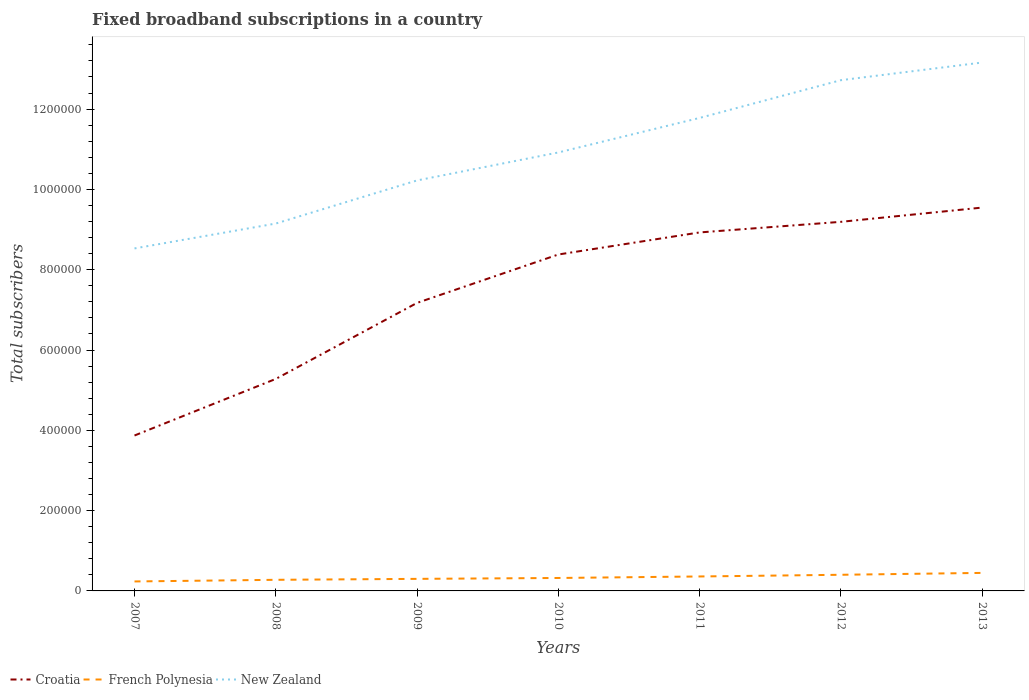Is the number of lines equal to the number of legend labels?
Your response must be concise. Yes. Across all years, what is the maximum number of broadband subscriptions in French Polynesia?
Provide a short and direct response. 2.36e+04. In which year was the number of broadband subscriptions in French Polynesia maximum?
Offer a terse response. 2007. What is the total number of broadband subscriptions in Croatia in the graph?
Your answer should be very brief. -2.64e+04. What is the difference between the highest and the second highest number of broadband subscriptions in Croatia?
Provide a succinct answer. 5.68e+05. What is the difference between the highest and the lowest number of broadband subscriptions in French Polynesia?
Ensure brevity in your answer.  3. How many lines are there?
Your answer should be compact. 3. What is the difference between two consecutive major ticks on the Y-axis?
Your answer should be compact. 2.00e+05. Does the graph contain any zero values?
Keep it short and to the point. No. Does the graph contain grids?
Keep it short and to the point. No. How many legend labels are there?
Keep it short and to the point. 3. What is the title of the graph?
Your response must be concise. Fixed broadband subscriptions in a country. What is the label or title of the Y-axis?
Your answer should be compact. Total subscribers. What is the Total subscribers in Croatia in 2007?
Provide a succinct answer. 3.87e+05. What is the Total subscribers in French Polynesia in 2007?
Make the answer very short. 2.36e+04. What is the Total subscribers of New Zealand in 2007?
Offer a terse response. 8.53e+05. What is the Total subscribers in Croatia in 2008?
Your answer should be compact. 5.28e+05. What is the Total subscribers of French Polynesia in 2008?
Keep it short and to the point. 2.77e+04. What is the Total subscribers of New Zealand in 2008?
Provide a short and direct response. 9.15e+05. What is the Total subscribers of Croatia in 2009?
Your response must be concise. 7.17e+05. What is the Total subscribers in French Polynesia in 2009?
Offer a terse response. 3.00e+04. What is the Total subscribers in New Zealand in 2009?
Provide a short and direct response. 1.02e+06. What is the Total subscribers of Croatia in 2010?
Your answer should be compact. 8.38e+05. What is the Total subscribers in French Polynesia in 2010?
Make the answer very short. 3.22e+04. What is the Total subscribers of New Zealand in 2010?
Give a very brief answer. 1.09e+06. What is the Total subscribers in Croatia in 2011?
Ensure brevity in your answer.  8.93e+05. What is the Total subscribers in French Polynesia in 2011?
Your answer should be very brief. 3.60e+04. What is the Total subscribers of New Zealand in 2011?
Provide a short and direct response. 1.18e+06. What is the Total subscribers of Croatia in 2012?
Provide a succinct answer. 9.19e+05. What is the Total subscribers of French Polynesia in 2012?
Keep it short and to the point. 4.02e+04. What is the Total subscribers in New Zealand in 2012?
Your response must be concise. 1.27e+06. What is the Total subscribers in Croatia in 2013?
Your answer should be very brief. 9.55e+05. What is the Total subscribers of French Polynesia in 2013?
Offer a terse response. 4.49e+04. What is the Total subscribers in New Zealand in 2013?
Your answer should be compact. 1.32e+06. Across all years, what is the maximum Total subscribers of Croatia?
Provide a succinct answer. 9.55e+05. Across all years, what is the maximum Total subscribers in French Polynesia?
Ensure brevity in your answer.  4.49e+04. Across all years, what is the maximum Total subscribers in New Zealand?
Provide a short and direct response. 1.32e+06. Across all years, what is the minimum Total subscribers of Croatia?
Offer a very short reply. 3.87e+05. Across all years, what is the minimum Total subscribers in French Polynesia?
Provide a succinct answer. 2.36e+04. Across all years, what is the minimum Total subscribers in New Zealand?
Your answer should be very brief. 8.53e+05. What is the total Total subscribers in Croatia in the graph?
Keep it short and to the point. 5.24e+06. What is the total Total subscribers in French Polynesia in the graph?
Your answer should be very brief. 2.35e+05. What is the total Total subscribers of New Zealand in the graph?
Keep it short and to the point. 7.65e+06. What is the difference between the Total subscribers of Croatia in 2007 and that in 2008?
Your answer should be very brief. -1.41e+05. What is the difference between the Total subscribers of French Polynesia in 2007 and that in 2008?
Make the answer very short. -4071. What is the difference between the Total subscribers in New Zealand in 2007 and that in 2008?
Provide a short and direct response. -6.19e+04. What is the difference between the Total subscribers in Croatia in 2007 and that in 2009?
Keep it short and to the point. -3.30e+05. What is the difference between the Total subscribers in French Polynesia in 2007 and that in 2009?
Your answer should be compact. -6430. What is the difference between the Total subscribers of New Zealand in 2007 and that in 2009?
Ensure brevity in your answer.  -1.69e+05. What is the difference between the Total subscribers of Croatia in 2007 and that in 2010?
Provide a short and direct response. -4.51e+05. What is the difference between the Total subscribers of French Polynesia in 2007 and that in 2010?
Keep it short and to the point. -8647. What is the difference between the Total subscribers of New Zealand in 2007 and that in 2010?
Ensure brevity in your answer.  -2.39e+05. What is the difference between the Total subscribers in Croatia in 2007 and that in 2011?
Ensure brevity in your answer.  -5.06e+05. What is the difference between the Total subscribers in French Polynesia in 2007 and that in 2011?
Provide a short and direct response. -1.24e+04. What is the difference between the Total subscribers of New Zealand in 2007 and that in 2011?
Make the answer very short. -3.25e+05. What is the difference between the Total subscribers of Croatia in 2007 and that in 2012?
Your answer should be very brief. -5.32e+05. What is the difference between the Total subscribers of French Polynesia in 2007 and that in 2012?
Your answer should be compact. -1.66e+04. What is the difference between the Total subscribers of New Zealand in 2007 and that in 2012?
Provide a short and direct response. -4.19e+05. What is the difference between the Total subscribers of Croatia in 2007 and that in 2013?
Offer a terse response. -5.68e+05. What is the difference between the Total subscribers in French Polynesia in 2007 and that in 2013?
Your response must be concise. -2.13e+04. What is the difference between the Total subscribers in New Zealand in 2007 and that in 2013?
Provide a succinct answer. -4.63e+05. What is the difference between the Total subscribers in Croatia in 2008 and that in 2009?
Ensure brevity in your answer.  -1.89e+05. What is the difference between the Total subscribers of French Polynesia in 2008 and that in 2009?
Make the answer very short. -2359. What is the difference between the Total subscribers in New Zealand in 2008 and that in 2009?
Keep it short and to the point. -1.07e+05. What is the difference between the Total subscribers in Croatia in 2008 and that in 2010?
Your answer should be very brief. -3.10e+05. What is the difference between the Total subscribers in French Polynesia in 2008 and that in 2010?
Provide a short and direct response. -4576. What is the difference between the Total subscribers in New Zealand in 2008 and that in 2010?
Your response must be concise. -1.77e+05. What is the difference between the Total subscribers of Croatia in 2008 and that in 2011?
Your answer should be compact. -3.65e+05. What is the difference between the Total subscribers of French Polynesia in 2008 and that in 2011?
Make the answer very short. -8329. What is the difference between the Total subscribers of New Zealand in 2008 and that in 2011?
Make the answer very short. -2.63e+05. What is the difference between the Total subscribers in Croatia in 2008 and that in 2012?
Provide a succinct answer. -3.91e+05. What is the difference between the Total subscribers in French Polynesia in 2008 and that in 2012?
Your answer should be compact. -1.25e+04. What is the difference between the Total subscribers of New Zealand in 2008 and that in 2012?
Your response must be concise. -3.57e+05. What is the difference between the Total subscribers of Croatia in 2008 and that in 2013?
Provide a short and direct response. -4.27e+05. What is the difference between the Total subscribers in French Polynesia in 2008 and that in 2013?
Give a very brief answer. -1.72e+04. What is the difference between the Total subscribers in New Zealand in 2008 and that in 2013?
Ensure brevity in your answer.  -4.01e+05. What is the difference between the Total subscribers in Croatia in 2009 and that in 2010?
Provide a succinct answer. -1.21e+05. What is the difference between the Total subscribers of French Polynesia in 2009 and that in 2010?
Give a very brief answer. -2217. What is the difference between the Total subscribers in New Zealand in 2009 and that in 2010?
Offer a very short reply. -6.97e+04. What is the difference between the Total subscribers in Croatia in 2009 and that in 2011?
Ensure brevity in your answer.  -1.75e+05. What is the difference between the Total subscribers in French Polynesia in 2009 and that in 2011?
Your response must be concise. -5970. What is the difference between the Total subscribers in New Zealand in 2009 and that in 2011?
Keep it short and to the point. -1.56e+05. What is the difference between the Total subscribers of Croatia in 2009 and that in 2012?
Ensure brevity in your answer.  -2.02e+05. What is the difference between the Total subscribers of French Polynesia in 2009 and that in 2012?
Provide a short and direct response. -1.02e+04. What is the difference between the Total subscribers of New Zealand in 2009 and that in 2012?
Keep it short and to the point. -2.50e+05. What is the difference between the Total subscribers of Croatia in 2009 and that in 2013?
Give a very brief answer. -2.37e+05. What is the difference between the Total subscribers of French Polynesia in 2009 and that in 2013?
Give a very brief answer. -1.49e+04. What is the difference between the Total subscribers of New Zealand in 2009 and that in 2013?
Your answer should be very brief. -2.94e+05. What is the difference between the Total subscribers in Croatia in 2010 and that in 2011?
Keep it short and to the point. -5.50e+04. What is the difference between the Total subscribers of French Polynesia in 2010 and that in 2011?
Provide a short and direct response. -3753. What is the difference between the Total subscribers of New Zealand in 2010 and that in 2011?
Keep it short and to the point. -8.60e+04. What is the difference between the Total subscribers of Croatia in 2010 and that in 2012?
Provide a succinct answer. -8.14e+04. What is the difference between the Total subscribers of French Polynesia in 2010 and that in 2012?
Your response must be concise. -7953. What is the difference between the Total subscribers of Croatia in 2010 and that in 2013?
Ensure brevity in your answer.  -1.17e+05. What is the difference between the Total subscribers of French Polynesia in 2010 and that in 2013?
Ensure brevity in your answer.  -1.27e+04. What is the difference between the Total subscribers in New Zealand in 2010 and that in 2013?
Offer a terse response. -2.24e+05. What is the difference between the Total subscribers in Croatia in 2011 and that in 2012?
Your answer should be very brief. -2.64e+04. What is the difference between the Total subscribers of French Polynesia in 2011 and that in 2012?
Give a very brief answer. -4200. What is the difference between the Total subscribers of New Zealand in 2011 and that in 2012?
Give a very brief answer. -9.40e+04. What is the difference between the Total subscribers of Croatia in 2011 and that in 2013?
Offer a terse response. -6.19e+04. What is the difference between the Total subscribers of French Polynesia in 2011 and that in 2013?
Your answer should be very brief. -8900. What is the difference between the Total subscribers in New Zealand in 2011 and that in 2013?
Your answer should be compact. -1.38e+05. What is the difference between the Total subscribers in Croatia in 2012 and that in 2013?
Your answer should be very brief. -3.55e+04. What is the difference between the Total subscribers in French Polynesia in 2012 and that in 2013?
Offer a terse response. -4700. What is the difference between the Total subscribers in New Zealand in 2012 and that in 2013?
Provide a short and direct response. -4.40e+04. What is the difference between the Total subscribers of Croatia in 2007 and the Total subscribers of French Polynesia in 2008?
Your answer should be compact. 3.59e+05. What is the difference between the Total subscribers of Croatia in 2007 and the Total subscribers of New Zealand in 2008?
Your answer should be very brief. -5.28e+05. What is the difference between the Total subscribers in French Polynesia in 2007 and the Total subscribers in New Zealand in 2008?
Your response must be concise. -8.91e+05. What is the difference between the Total subscribers of Croatia in 2007 and the Total subscribers of French Polynesia in 2009?
Offer a terse response. 3.57e+05. What is the difference between the Total subscribers in Croatia in 2007 and the Total subscribers in New Zealand in 2009?
Offer a very short reply. -6.35e+05. What is the difference between the Total subscribers of French Polynesia in 2007 and the Total subscribers of New Zealand in 2009?
Give a very brief answer. -9.99e+05. What is the difference between the Total subscribers of Croatia in 2007 and the Total subscribers of French Polynesia in 2010?
Offer a terse response. 3.55e+05. What is the difference between the Total subscribers in Croatia in 2007 and the Total subscribers in New Zealand in 2010?
Give a very brief answer. -7.05e+05. What is the difference between the Total subscribers in French Polynesia in 2007 and the Total subscribers in New Zealand in 2010?
Provide a short and direct response. -1.07e+06. What is the difference between the Total subscribers in Croatia in 2007 and the Total subscribers in French Polynesia in 2011?
Ensure brevity in your answer.  3.51e+05. What is the difference between the Total subscribers of Croatia in 2007 and the Total subscribers of New Zealand in 2011?
Provide a short and direct response. -7.91e+05. What is the difference between the Total subscribers in French Polynesia in 2007 and the Total subscribers in New Zealand in 2011?
Provide a short and direct response. -1.15e+06. What is the difference between the Total subscribers of Croatia in 2007 and the Total subscribers of French Polynesia in 2012?
Make the answer very short. 3.47e+05. What is the difference between the Total subscribers in Croatia in 2007 and the Total subscribers in New Zealand in 2012?
Offer a terse response. -8.85e+05. What is the difference between the Total subscribers in French Polynesia in 2007 and the Total subscribers in New Zealand in 2012?
Your answer should be very brief. -1.25e+06. What is the difference between the Total subscribers of Croatia in 2007 and the Total subscribers of French Polynesia in 2013?
Your answer should be very brief. 3.42e+05. What is the difference between the Total subscribers of Croatia in 2007 and the Total subscribers of New Zealand in 2013?
Your response must be concise. -9.29e+05. What is the difference between the Total subscribers in French Polynesia in 2007 and the Total subscribers in New Zealand in 2013?
Provide a succinct answer. -1.29e+06. What is the difference between the Total subscribers in Croatia in 2008 and the Total subscribers in French Polynesia in 2009?
Offer a terse response. 4.98e+05. What is the difference between the Total subscribers of Croatia in 2008 and the Total subscribers of New Zealand in 2009?
Give a very brief answer. -4.94e+05. What is the difference between the Total subscribers of French Polynesia in 2008 and the Total subscribers of New Zealand in 2009?
Your answer should be very brief. -9.95e+05. What is the difference between the Total subscribers of Croatia in 2008 and the Total subscribers of French Polynesia in 2010?
Provide a short and direct response. 4.96e+05. What is the difference between the Total subscribers of Croatia in 2008 and the Total subscribers of New Zealand in 2010?
Provide a succinct answer. -5.64e+05. What is the difference between the Total subscribers in French Polynesia in 2008 and the Total subscribers in New Zealand in 2010?
Your answer should be very brief. -1.06e+06. What is the difference between the Total subscribers of Croatia in 2008 and the Total subscribers of French Polynesia in 2011?
Your response must be concise. 4.92e+05. What is the difference between the Total subscribers of Croatia in 2008 and the Total subscribers of New Zealand in 2011?
Offer a terse response. -6.50e+05. What is the difference between the Total subscribers in French Polynesia in 2008 and the Total subscribers in New Zealand in 2011?
Offer a very short reply. -1.15e+06. What is the difference between the Total subscribers in Croatia in 2008 and the Total subscribers in French Polynesia in 2012?
Your response must be concise. 4.88e+05. What is the difference between the Total subscribers in Croatia in 2008 and the Total subscribers in New Zealand in 2012?
Your answer should be compact. -7.44e+05. What is the difference between the Total subscribers in French Polynesia in 2008 and the Total subscribers in New Zealand in 2012?
Your response must be concise. -1.24e+06. What is the difference between the Total subscribers in Croatia in 2008 and the Total subscribers in French Polynesia in 2013?
Your answer should be compact. 4.83e+05. What is the difference between the Total subscribers of Croatia in 2008 and the Total subscribers of New Zealand in 2013?
Ensure brevity in your answer.  -7.88e+05. What is the difference between the Total subscribers in French Polynesia in 2008 and the Total subscribers in New Zealand in 2013?
Provide a succinct answer. -1.29e+06. What is the difference between the Total subscribers of Croatia in 2009 and the Total subscribers of French Polynesia in 2010?
Offer a terse response. 6.85e+05. What is the difference between the Total subscribers of Croatia in 2009 and the Total subscribers of New Zealand in 2010?
Your response must be concise. -3.75e+05. What is the difference between the Total subscribers in French Polynesia in 2009 and the Total subscribers in New Zealand in 2010?
Provide a short and direct response. -1.06e+06. What is the difference between the Total subscribers of Croatia in 2009 and the Total subscribers of French Polynesia in 2011?
Provide a succinct answer. 6.81e+05. What is the difference between the Total subscribers in Croatia in 2009 and the Total subscribers in New Zealand in 2011?
Provide a succinct answer. -4.61e+05. What is the difference between the Total subscribers of French Polynesia in 2009 and the Total subscribers of New Zealand in 2011?
Offer a terse response. -1.15e+06. What is the difference between the Total subscribers in Croatia in 2009 and the Total subscribers in French Polynesia in 2012?
Keep it short and to the point. 6.77e+05. What is the difference between the Total subscribers of Croatia in 2009 and the Total subscribers of New Zealand in 2012?
Your response must be concise. -5.55e+05. What is the difference between the Total subscribers in French Polynesia in 2009 and the Total subscribers in New Zealand in 2012?
Your answer should be compact. -1.24e+06. What is the difference between the Total subscribers in Croatia in 2009 and the Total subscribers in French Polynesia in 2013?
Offer a terse response. 6.72e+05. What is the difference between the Total subscribers in Croatia in 2009 and the Total subscribers in New Zealand in 2013?
Your response must be concise. -5.99e+05. What is the difference between the Total subscribers of French Polynesia in 2009 and the Total subscribers of New Zealand in 2013?
Provide a short and direct response. -1.29e+06. What is the difference between the Total subscribers of Croatia in 2010 and the Total subscribers of French Polynesia in 2011?
Provide a succinct answer. 8.02e+05. What is the difference between the Total subscribers in Croatia in 2010 and the Total subscribers in New Zealand in 2011?
Keep it short and to the point. -3.40e+05. What is the difference between the Total subscribers of French Polynesia in 2010 and the Total subscribers of New Zealand in 2011?
Give a very brief answer. -1.15e+06. What is the difference between the Total subscribers of Croatia in 2010 and the Total subscribers of French Polynesia in 2012?
Provide a short and direct response. 7.98e+05. What is the difference between the Total subscribers in Croatia in 2010 and the Total subscribers in New Zealand in 2012?
Offer a very short reply. -4.34e+05. What is the difference between the Total subscribers in French Polynesia in 2010 and the Total subscribers in New Zealand in 2012?
Ensure brevity in your answer.  -1.24e+06. What is the difference between the Total subscribers of Croatia in 2010 and the Total subscribers of French Polynesia in 2013?
Your response must be concise. 7.93e+05. What is the difference between the Total subscribers of Croatia in 2010 and the Total subscribers of New Zealand in 2013?
Your answer should be very brief. -4.78e+05. What is the difference between the Total subscribers in French Polynesia in 2010 and the Total subscribers in New Zealand in 2013?
Your answer should be very brief. -1.28e+06. What is the difference between the Total subscribers in Croatia in 2011 and the Total subscribers in French Polynesia in 2012?
Your answer should be very brief. 8.53e+05. What is the difference between the Total subscribers in Croatia in 2011 and the Total subscribers in New Zealand in 2012?
Provide a succinct answer. -3.79e+05. What is the difference between the Total subscribers of French Polynesia in 2011 and the Total subscribers of New Zealand in 2012?
Offer a terse response. -1.24e+06. What is the difference between the Total subscribers of Croatia in 2011 and the Total subscribers of French Polynesia in 2013?
Provide a succinct answer. 8.48e+05. What is the difference between the Total subscribers of Croatia in 2011 and the Total subscribers of New Zealand in 2013?
Provide a succinct answer. -4.23e+05. What is the difference between the Total subscribers in French Polynesia in 2011 and the Total subscribers in New Zealand in 2013?
Make the answer very short. -1.28e+06. What is the difference between the Total subscribers of Croatia in 2012 and the Total subscribers of French Polynesia in 2013?
Provide a succinct answer. 8.74e+05. What is the difference between the Total subscribers in Croatia in 2012 and the Total subscribers in New Zealand in 2013?
Your answer should be compact. -3.97e+05. What is the difference between the Total subscribers in French Polynesia in 2012 and the Total subscribers in New Zealand in 2013?
Ensure brevity in your answer.  -1.28e+06. What is the average Total subscribers of Croatia per year?
Give a very brief answer. 7.48e+05. What is the average Total subscribers in French Polynesia per year?
Make the answer very short. 3.35e+04. What is the average Total subscribers in New Zealand per year?
Offer a very short reply. 1.09e+06. In the year 2007, what is the difference between the Total subscribers of Croatia and Total subscribers of French Polynesia?
Ensure brevity in your answer.  3.63e+05. In the year 2007, what is the difference between the Total subscribers of Croatia and Total subscribers of New Zealand?
Your response must be concise. -4.66e+05. In the year 2007, what is the difference between the Total subscribers of French Polynesia and Total subscribers of New Zealand?
Provide a short and direct response. -8.29e+05. In the year 2008, what is the difference between the Total subscribers of Croatia and Total subscribers of French Polynesia?
Your answer should be very brief. 5.00e+05. In the year 2008, what is the difference between the Total subscribers of Croatia and Total subscribers of New Zealand?
Your answer should be compact. -3.87e+05. In the year 2008, what is the difference between the Total subscribers of French Polynesia and Total subscribers of New Zealand?
Your answer should be compact. -8.87e+05. In the year 2009, what is the difference between the Total subscribers in Croatia and Total subscribers in French Polynesia?
Provide a short and direct response. 6.87e+05. In the year 2009, what is the difference between the Total subscribers of Croatia and Total subscribers of New Zealand?
Ensure brevity in your answer.  -3.05e+05. In the year 2009, what is the difference between the Total subscribers in French Polynesia and Total subscribers in New Zealand?
Offer a terse response. -9.92e+05. In the year 2010, what is the difference between the Total subscribers in Croatia and Total subscribers in French Polynesia?
Your answer should be very brief. 8.06e+05. In the year 2010, what is the difference between the Total subscribers in Croatia and Total subscribers in New Zealand?
Keep it short and to the point. -2.54e+05. In the year 2010, what is the difference between the Total subscribers of French Polynesia and Total subscribers of New Zealand?
Give a very brief answer. -1.06e+06. In the year 2011, what is the difference between the Total subscribers of Croatia and Total subscribers of French Polynesia?
Your response must be concise. 8.57e+05. In the year 2011, what is the difference between the Total subscribers in Croatia and Total subscribers in New Zealand?
Offer a very short reply. -2.85e+05. In the year 2011, what is the difference between the Total subscribers of French Polynesia and Total subscribers of New Zealand?
Offer a very short reply. -1.14e+06. In the year 2012, what is the difference between the Total subscribers in Croatia and Total subscribers in French Polynesia?
Ensure brevity in your answer.  8.79e+05. In the year 2012, what is the difference between the Total subscribers in Croatia and Total subscribers in New Zealand?
Provide a short and direct response. -3.53e+05. In the year 2012, what is the difference between the Total subscribers of French Polynesia and Total subscribers of New Zealand?
Ensure brevity in your answer.  -1.23e+06. In the year 2013, what is the difference between the Total subscribers of Croatia and Total subscribers of French Polynesia?
Offer a terse response. 9.10e+05. In the year 2013, what is the difference between the Total subscribers in Croatia and Total subscribers in New Zealand?
Provide a short and direct response. -3.61e+05. In the year 2013, what is the difference between the Total subscribers in French Polynesia and Total subscribers in New Zealand?
Provide a succinct answer. -1.27e+06. What is the ratio of the Total subscribers of Croatia in 2007 to that in 2008?
Your response must be concise. 0.73. What is the ratio of the Total subscribers in French Polynesia in 2007 to that in 2008?
Make the answer very short. 0.85. What is the ratio of the Total subscribers in New Zealand in 2007 to that in 2008?
Make the answer very short. 0.93. What is the ratio of the Total subscribers in Croatia in 2007 to that in 2009?
Ensure brevity in your answer.  0.54. What is the ratio of the Total subscribers of French Polynesia in 2007 to that in 2009?
Your answer should be compact. 0.79. What is the ratio of the Total subscribers of New Zealand in 2007 to that in 2009?
Make the answer very short. 0.83. What is the ratio of the Total subscribers of Croatia in 2007 to that in 2010?
Make the answer very short. 0.46. What is the ratio of the Total subscribers of French Polynesia in 2007 to that in 2010?
Give a very brief answer. 0.73. What is the ratio of the Total subscribers of New Zealand in 2007 to that in 2010?
Provide a succinct answer. 0.78. What is the ratio of the Total subscribers in Croatia in 2007 to that in 2011?
Ensure brevity in your answer.  0.43. What is the ratio of the Total subscribers in French Polynesia in 2007 to that in 2011?
Offer a very short reply. 0.66. What is the ratio of the Total subscribers in New Zealand in 2007 to that in 2011?
Offer a very short reply. 0.72. What is the ratio of the Total subscribers in Croatia in 2007 to that in 2012?
Keep it short and to the point. 0.42. What is the ratio of the Total subscribers in French Polynesia in 2007 to that in 2012?
Your answer should be very brief. 0.59. What is the ratio of the Total subscribers of New Zealand in 2007 to that in 2012?
Give a very brief answer. 0.67. What is the ratio of the Total subscribers of Croatia in 2007 to that in 2013?
Make the answer very short. 0.41. What is the ratio of the Total subscribers of French Polynesia in 2007 to that in 2013?
Your answer should be very brief. 0.53. What is the ratio of the Total subscribers of New Zealand in 2007 to that in 2013?
Provide a succinct answer. 0.65. What is the ratio of the Total subscribers in Croatia in 2008 to that in 2009?
Your response must be concise. 0.74. What is the ratio of the Total subscribers of French Polynesia in 2008 to that in 2009?
Give a very brief answer. 0.92. What is the ratio of the Total subscribers in New Zealand in 2008 to that in 2009?
Your answer should be very brief. 0.9. What is the ratio of the Total subscribers of Croatia in 2008 to that in 2010?
Your response must be concise. 0.63. What is the ratio of the Total subscribers of French Polynesia in 2008 to that in 2010?
Ensure brevity in your answer.  0.86. What is the ratio of the Total subscribers in New Zealand in 2008 to that in 2010?
Provide a short and direct response. 0.84. What is the ratio of the Total subscribers in Croatia in 2008 to that in 2011?
Keep it short and to the point. 0.59. What is the ratio of the Total subscribers of French Polynesia in 2008 to that in 2011?
Ensure brevity in your answer.  0.77. What is the ratio of the Total subscribers in New Zealand in 2008 to that in 2011?
Your answer should be compact. 0.78. What is the ratio of the Total subscribers of Croatia in 2008 to that in 2012?
Ensure brevity in your answer.  0.57. What is the ratio of the Total subscribers in French Polynesia in 2008 to that in 2012?
Offer a terse response. 0.69. What is the ratio of the Total subscribers in New Zealand in 2008 to that in 2012?
Your answer should be very brief. 0.72. What is the ratio of the Total subscribers of Croatia in 2008 to that in 2013?
Offer a very short reply. 0.55. What is the ratio of the Total subscribers of French Polynesia in 2008 to that in 2013?
Your answer should be compact. 0.62. What is the ratio of the Total subscribers in New Zealand in 2008 to that in 2013?
Make the answer very short. 0.7. What is the ratio of the Total subscribers in Croatia in 2009 to that in 2010?
Your answer should be very brief. 0.86. What is the ratio of the Total subscribers in French Polynesia in 2009 to that in 2010?
Offer a terse response. 0.93. What is the ratio of the Total subscribers of New Zealand in 2009 to that in 2010?
Your response must be concise. 0.94. What is the ratio of the Total subscribers in Croatia in 2009 to that in 2011?
Give a very brief answer. 0.8. What is the ratio of the Total subscribers in French Polynesia in 2009 to that in 2011?
Offer a very short reply. 0.83. What is the ratio of the Total subscribers of New Zealand in 2009 to that in 2011?
Keep it short and to the point. 0.87. What is the ratio of the Total subscribers in Croatia in 2009 to that in 2012?
Provide a short and direct response. 0.78. What is the ratio of the Total subscribers in French Polynesia in 2009 to that in 2012?
Provide a succinct answer. 0.75. What is the ratio of the Total subscribers in New Zealand in 2009 to that in 2012?
Provide a short and direct response. 0.8. What is the ratio of the Total subscribers of Croatia in 2009 to that in 2013?
Offer a very short reply. 0.75. What is the ratio of the Total subscribers in French Polynesia in 2009 to that in 2013?
Ensure brevity in your answer.  0.67. What is the ratio of the Total subscribers of New Zealand in 2009 to that in 2013?
Your answer should be compact. 0.78. What is the ratio of the Total subscribers in Croatia in 2010 to that in 2011?
Offer a terse response. 0.94. What is the ratio of the Total subscribers of French Polynesia in 2010 to that in 2011?
Provide a succinct answer. 0.9. What is the ratio of the Total subscribers in New Zealand in 2010 to that in 2011?
Provide a short and direct response. 0.93. What is the ratio of the Total subscribers of Croatia in 2010 to that in 2012?
Your response must be concise. 0.91. What is the ratio of the Total subscribers of French Polynesia in 2010 to that in 2012?
Offer a very short reply. 0.8. What is the ratio of the Total subscribers in New Zealand in 2010 to that in 2012?
Provide a short and direct response. 0.86. What is the ratio of the Total subscribers in Croatia in 2010 to that in 2013?
Offer a terse response. 0.88. What is the ratio of the Total subscribers in French Polynesia in 2010 to that in 2013?
Your answer should be compact. 0.72. What is the ratio of the Total subscribers in New Zealand in 2010 to that in 2013?
Offer a very short reply. 0.83. What is the ratio of the Total subscribers of Croatia in 2011 to that in 2012?
Your answer should be very brief. 0.97. What is the ratio of the Total subscribers of French Polynesia in 2011 to that in 2012?
Provide a short and direct response. 0.9. What is the ratio of the Total subscribers in New Zealand in 2011 to that in 2012?
Offer a very short reply. 0.93. What is the ratio of the Total subscribers in Croatia in 2011 to that in 2013?
Keep it short and to the point. 0.94. What is the ratio of the Total subscribers in French Polynesia in 2011 to that in 2013?
Your answer should be compact. 0.8. What is the ratio of the Total subscribers of New Zealand in 2011 to that in 2013?
Your response must be concise. 0.9. What is the ratio of the Total subscribers of Croatia in 2012 to that in 2013?
Your answer should be very brief. 0.96. What is the ratio of the Total subscribers in French Polynesia in 2012 to that in 2013?
Make the answer very short. 0.9. What is the ratio of the Total subscribers of New Zealand in 2012 to that in 2013?
Keep it short and to the point. 0.97. What is the difference between the highest and the second highest Total subscribers in Croatia?
Your answer should be very brief. 3.55e+04. What is the difference between the highest and the second highest Total subscribers of French Polynesia?
Keep it short and to the point. 4700. What is the difference between the highest and the second highest Total subscribers of New Zealand?
Offer a terse response. 4.40e+04. What is the difference between the highest and the lowest Total subscribers of Croatia?
Ensure brevity in your answer.  5.68e+05. What is the difference between the highest and the lowest Total subscribers in French Polynesia?
Give a very brief answer. 2.13e+04. What is the difference between the highest and the lowest Total subscribers in New Zealand?
Offer a very short reply. 4.63e+05. 